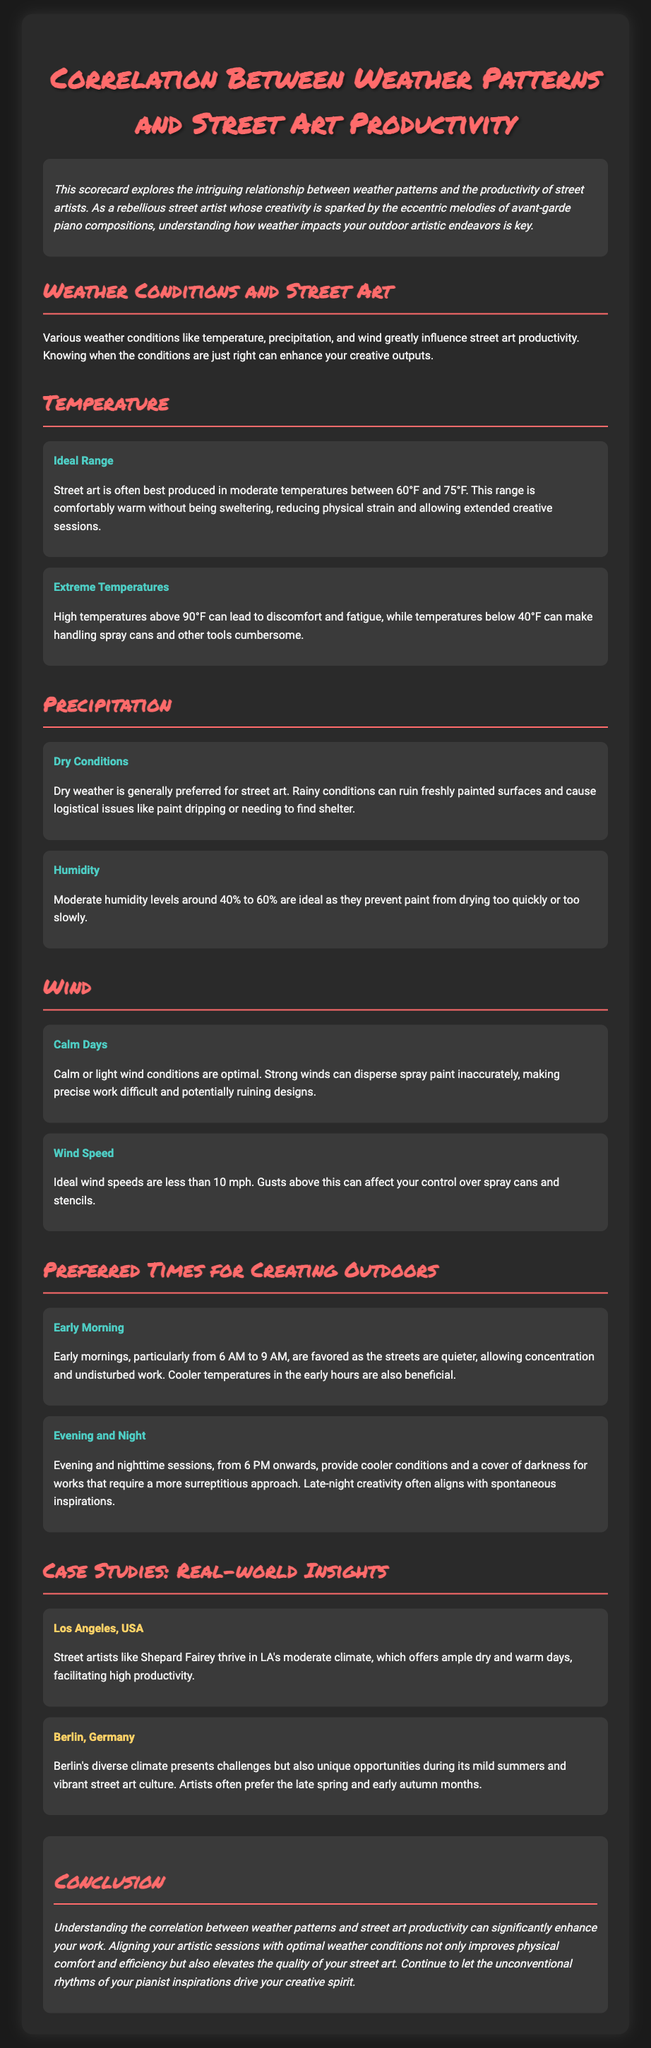What is the ideal temperature range for street art? The ideal temperature range for street art is mentioned as comfortably warm without being sweltering, which is between 60°F and 75°F.
Answer: 60°F to 75°F What time is favored for early morning sessions? The document states that early morning sessions are particularly favored from 6 AM to 9 AM.
Answer: 6 AM to 9 AM What humidity level is ideal for painting? It specifies that moderate humidity levels around 40% to 60% are ideal since they prevent paint from drying too quickly or too slowly.
Answer: 40% to 60% What wind speed is considered ideal for street art? The ideal wind speed is noted as less than 10 mph for optimal control over spray cans.
Answer: Less than 10 mph Which city's climate helps artists like Shepard Fairey thrive? The document highlights Los Angeles as a city where street artists thrive due to its moderate climate.
Answer: Los Angeles What conditions hinder street art production during rainfall? Rainy conditions are noted to ruin freshly painted surfaces and cause logistical issues, making dry conditions preferred.
Answer: Rainy conditions What are the benefits of evening sessions for street artists? Evening and nighttime sessions provide cooler conditions and cover for more surreptitious work, aligning with spontaneous inspirations.
Answer: Cooler conditions During which seasons do Berlin artists prefer to work? The document mentions that artists in Berlin often prefer the late spring and early autumn months, highlighting the temperatures and culture of the area.
Answer: Late spring and early autumn How does temperature impact handling of spray cans? The document notes that extreme temperatures below 40°F make handling spray cans cumbersome.
Answer: Below 40°F 